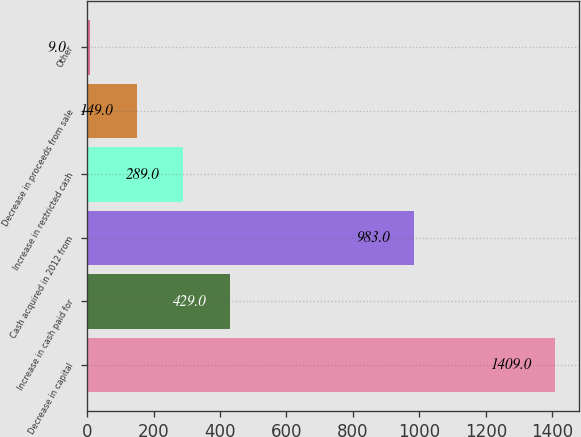<chart> <loc_0><loc_0><loc_500><loc_500><bar_chart><fcel>Decrease in capital<fcel>Increase in cash paid for<fcel>Cash acquired in 2012 from<fcel>Increase in restricted cash<fcel>Decrease in proceeds from sale<fcel>Other<nl><fcel>1409<fcel>429<fcel>983<fcel>289<fcel>149<fcel>9<nl></chart> 